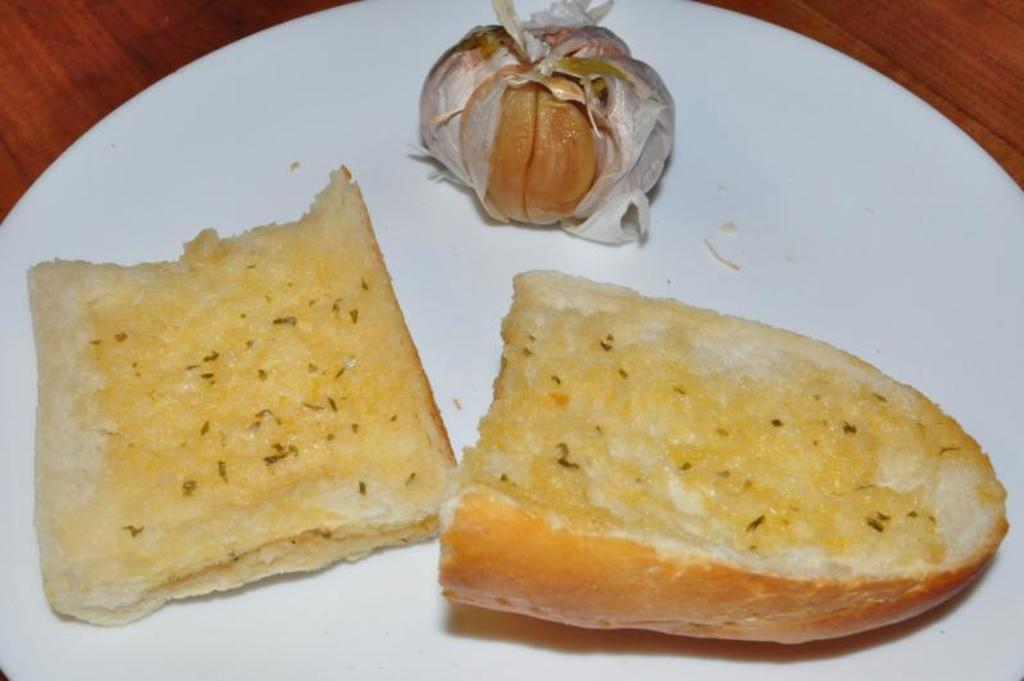What is on the plate in the image? There are food items on a plate. What is the plate resting on? The plate is placed on a wooden platform. How many cherries are on the plate in the image? There is no information about cherries in the image, so we cannot determine the number of cherries. What type of bean is present in the image? There is no bean present in the image. Is there a mitten on the wooden platform in the image? There is no mitten present in the image. 